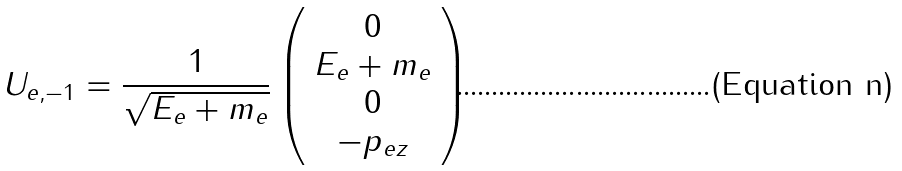Convert formula to latex. <formula><loc_0><loc_0><loc_500><loc_500>U _ { e , - 1 } = \frac { 1 } { \sqrt { E _ { e } + m _ { e } } } \left ( \begin{array} { c } { 0 } \\ { { E _ { e } + m _ { e } } } \\ { 0 } \\ { { - p _ { e z } } } \end{array} \right )</formula> 